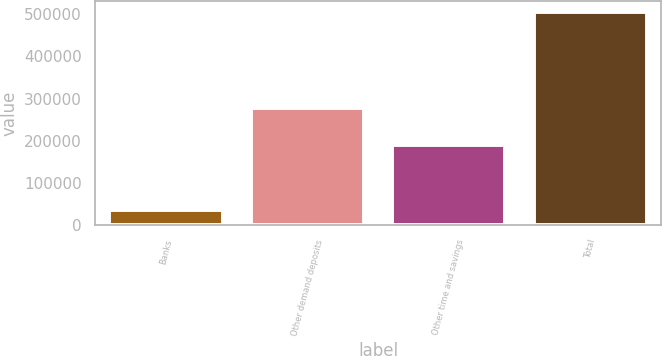<chart> <loc_0><loc_0><loc_500><loc_500><bar_chart><fcel>Banks<fcel>Other demand deposits<fcel>Other time and savings<fcel>Total<nl><fcel>36983<fcel>278745<fcel>189049<fcel>504777<nl></chart> 